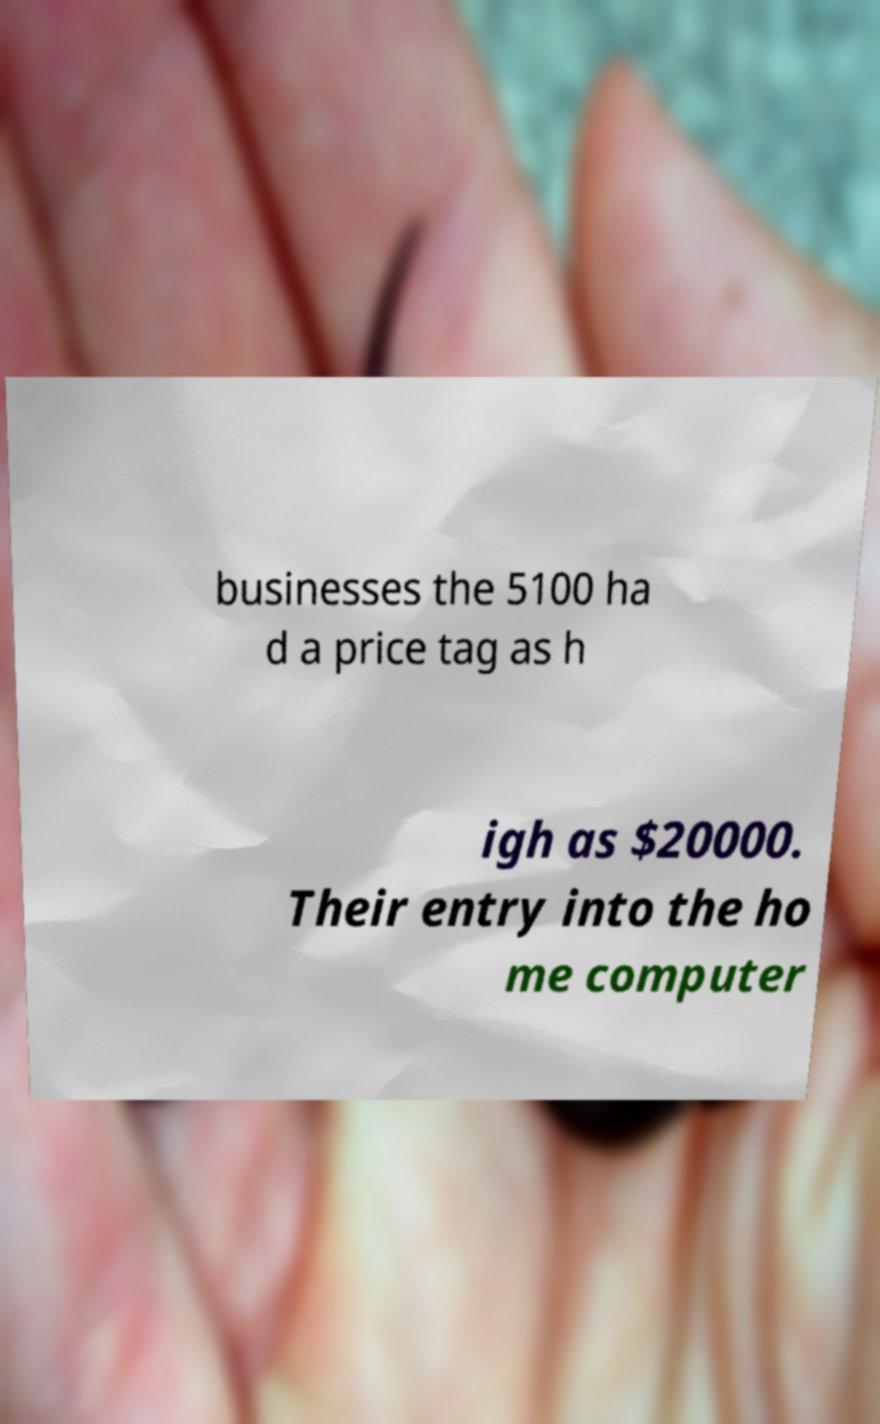Could you assist in decoding the text presented in this image and type it out clearly? businesses the 5100 ha d a price tag as h igh as $20000. Their entry into the ho me computer 